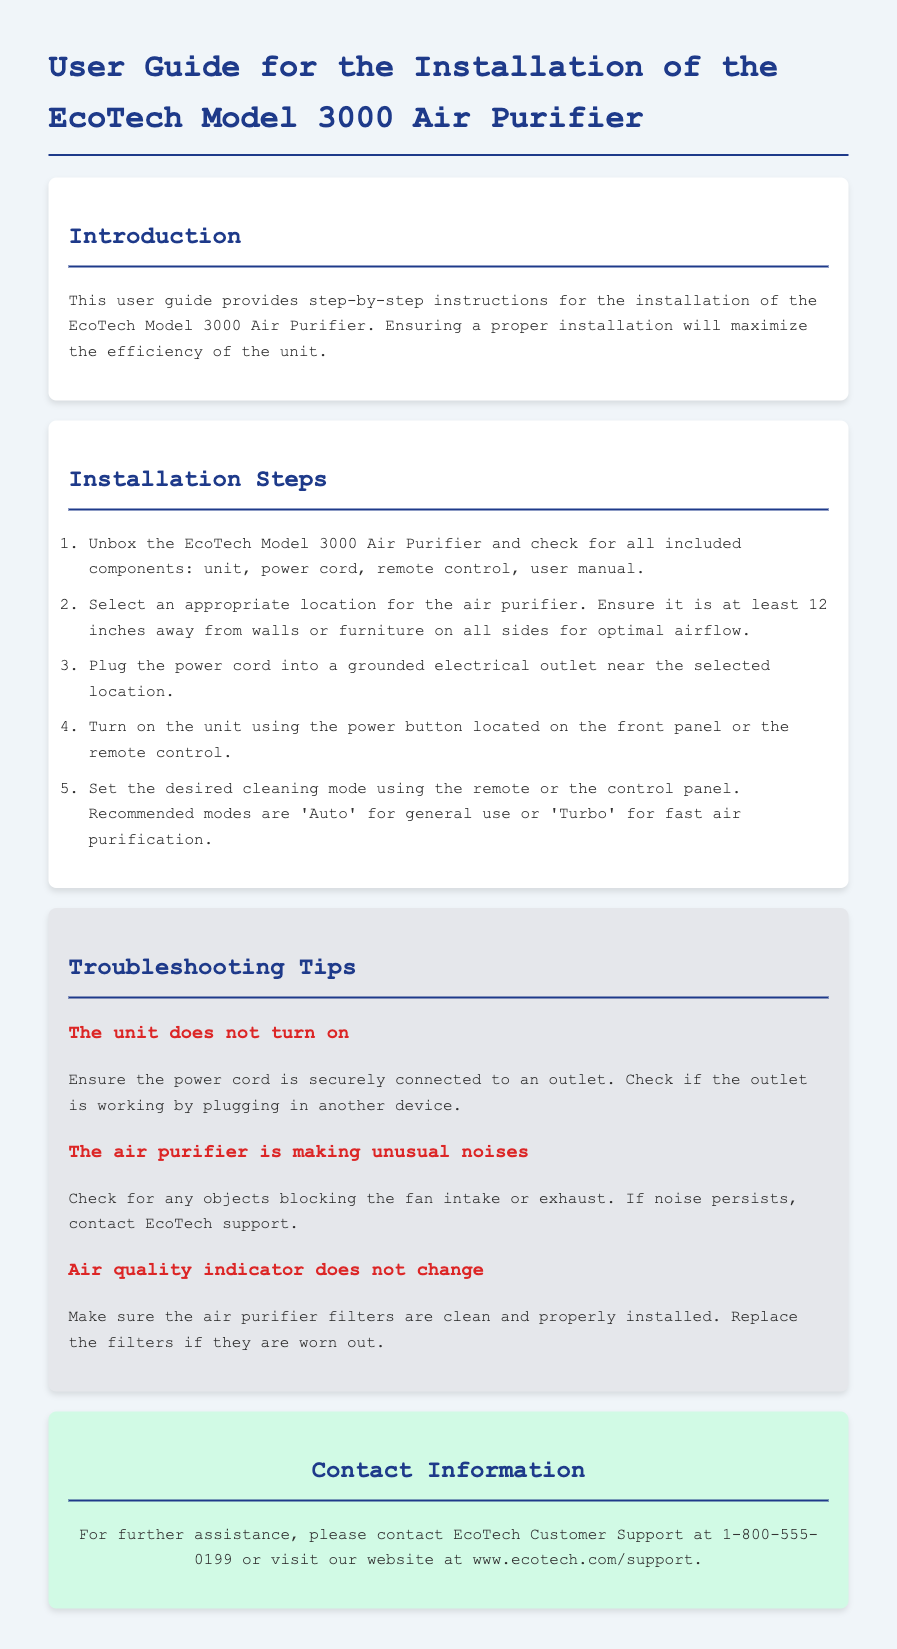What is the model of the air purifier? The model of the air purifier is stated in the title of the document.
Answer: EcoTech Model 3000 How far should the air purifier be from walls or furniture? The required distance for optimal airflow is mentioned in the installation steps.
Answer: 12 inches What is the contact number for EcoTech Customer Support? The contact information section lists the phone number for assistance.
Answer: 1-800-555-0199 What are the recommended cleaning modes? The installation steps state the recommended modes for use of the unit.
Answer: Auto and Turbo What should you do if the unit does not turn on? The troubleshooting tips provide actions to take when the unit does not operate.
Answer: Check power cord connection Why might the air quality indicator not change? The troubleshooting section explains potential reasons for this issue.
Answer: Filters may be dirty or improperly installed 